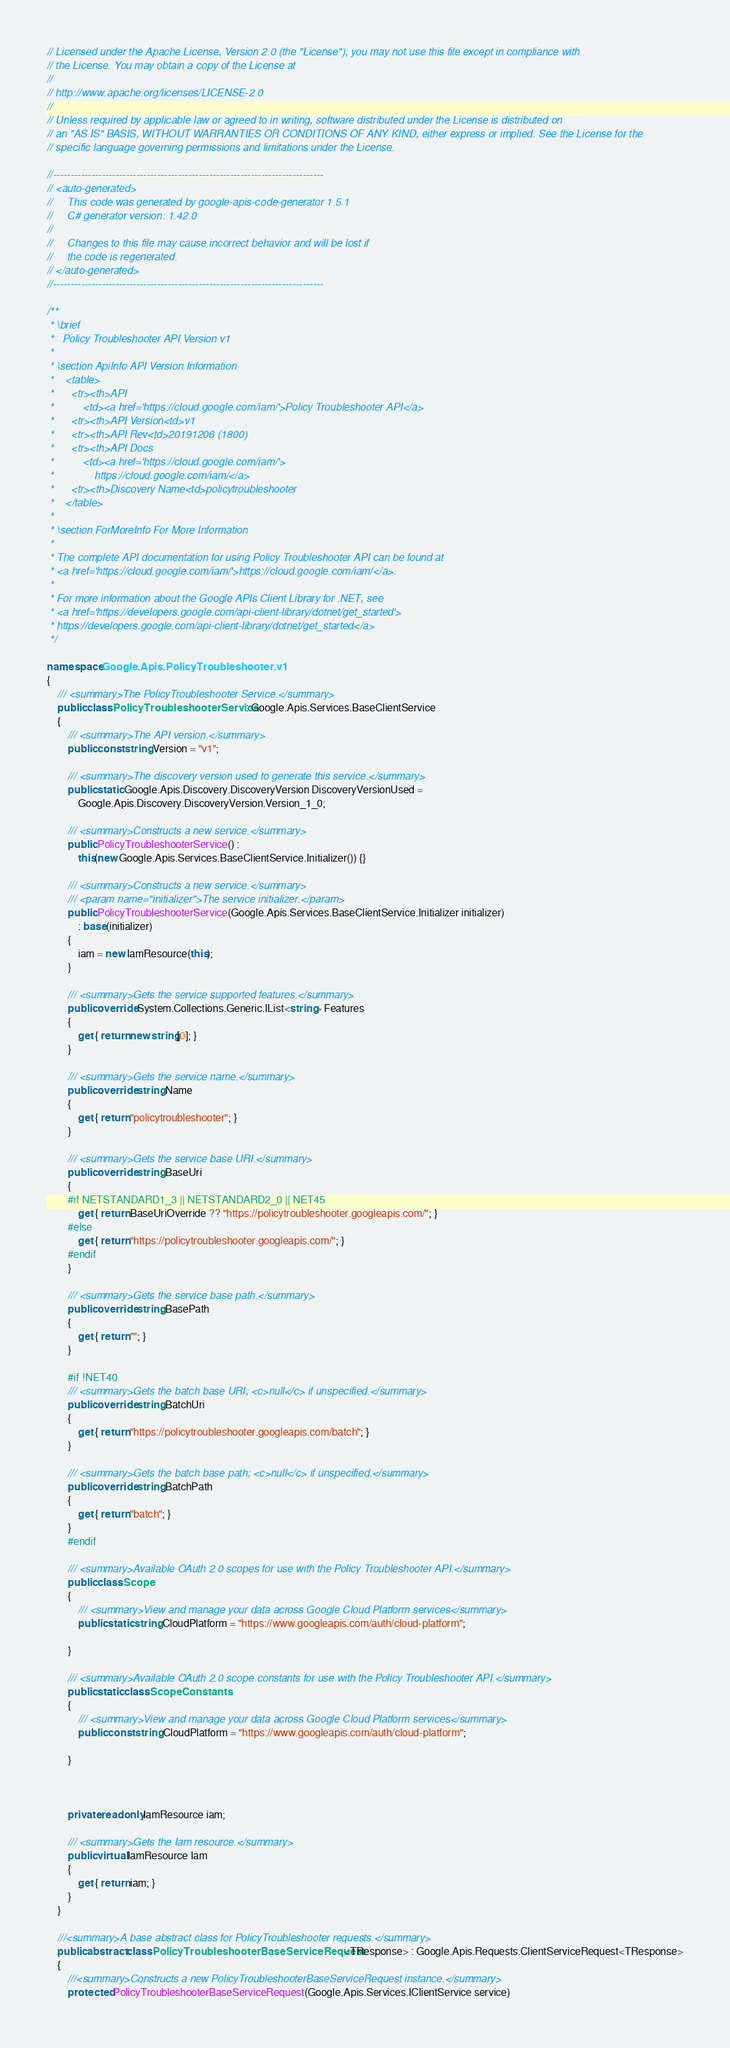Convert code to text. <code><loc_0><loc_0><loc_500><loc_500><_C#_>// Licensed under the Apache License, Version 2.0 (the "License"); you may not use this file except in compliance with
// the License. You may obtain a copy of the License at
//
// http://www.apache.org/licenses/LICENSE-2.0
//
// Unless required by applicable law or agreed to in writing, software distributed under the License is distributed on
// an "AS IS" BASIS, WITHOUT WARRANTIES OR CONDITIONS OF ANY KIND, either express or implied. See the License for the
// specific language governing permissions and limitations under the License.

//------------------------------------------------------------------------------
// <auto-generated>
//     This code was generated by google-apis-code-generator 1.5.1
//     C# generator version: 1.42.0
//
//     Changes to this file may cause incorrect behavior and will be lost if
//     the code is regenerated.
// </auto-generated>
//------------------------------------------------------------------------------

/**
 * \brief
 *   Policy Troubleshooter API Version v1
 *
 * \section ApiInfo API Version Information
 *    <table>
 *      <tr><th>API
 *          <td><a href='https://cloud.google.com/iam/'>Policy Troubleshooter API</a>
 *      <tr><th>API Version<td>v1
 *      <tr><th>API Rev<td>20191206 (1800)
 *      <tr><th>API Docs
 *          <td><a href='https://cloud.google.com/iam/'>
 *              https://cloud.google.com/iam/</a>
 *      <tr><th>Discovery Name<td>policytroubleshooter
 *    </table>
 *
 * \section ForMoreInfo For More Information
 *
 * The complete API documentation for using Policy Troubleshooter API can be found at
 * <a href='https://cloud.google.com/iam/'>https://cloud.google.com/iam/</a>.
 *
 * For more information about the Google APIs Client Library for .NET, see
 * <a href='https://developers.google.com/api-client-library/dotnet/get_started'>
 * https://developers.google.com/api-client-library/dotnet/get_started</a>
 */

namespace Google.Apis.PolicyTroubleshooter.v1
{
    /// <summary>The PolicyTroubleshooter Service.</summary>
    public class PolicyTroubleshooterService : Google.Apis.Services.BaseClientService
    {
        /// <summary>The API version.</summary>
        public const string Version = "v1";

        /// <summary>The discovery version used to generate this service.</summary>
        public static Google.Apis.Discovery.DiscoveryVersion DiscoveryVersionUsed =
            Google.Apis.Discovery.DiscoveryVersion.Version_1_0;

        /// <summary>Constructs a new service.</summary>
        public PolicyTroubleshooterService() :
            this(new Google.Apis.Services.BaseClientService.Initializer()) {}

        /// <summary>Constructs a new service.</summary>
        /// <param name="initializer">The service initializer.</param>
        public PolicyTroubleshooterService(Google.Apis.Services.BaseClientService.Initializer initializer)
            : base(initializer)
        {
            iam = new IamResource(this);
        }

        /// <summary>Gets the service supported features.</summary>
        public override System.Collections.Generic.IList<string> Features
        {
            get { return new string[0]; }
        }

        /// <summary>Gets the service name.</summary>
        public override string Name
        {
            get { return "policytroubleshooter"; }
        }

        /// <summary>Gets the service base URI.</summary>
        public override string BaseUri
        {
        #if NETSTANDARD1_3 || NETSTANDARD2_0 || NET45
            get { return BaseUriOverride ?? "https://policytroubleshooter.googleapis.com/"; }
        #else
            get { return "https://policytroubleshooter.googleapis.com/"; }
        #endif
        }

        /// <summary>Gets the service base path.</summary>
        public override string BasePath
        {
            get { return ""; }
        }

        #if !NET40
        /// <summary>Gets the batch base URI; <c>null</c> if unspecified.</summary>
        public override string BatchUri
        {
            get { return "https://policytroubleshooter.googleapis.com/batch"; }
        }

        /// <summary>Gets the batch base path; <c>null</c> if unspecified.</summary>
        public override string BatchPath
        {
            get { return "batch"; }
        }
        #endif

        /// <summary>Available OAuth 2.0 scopes for use with the Policy Troubleshooter API.</summary>
        public class Scope
        {
            /// <summary>View and manage your data across Google Cloud Platform services</summary>
            public static string CloudPlatform = "https://www.googleapis.com/auth/cloud-platform";

        }

        /// <summary>Available OAuth 2.0 scope constants for use with the Policy Troubleshooter API.</summary>
        public static class ScopeConstants
        {
            /// <summary>View and manage your data across Google Cloud Platform services</summary>
            public const string CloudPlatform = "https://www.googleapis.com/auth/cloud-platform";

        }



        private readonly IamResource iam;

        /// <summary>Gets the Iam resource.</summary>
        public virtual IamResource Iam
        {
            get { return iam; }
        }
    }

    ///<summary>A base abstract class for PolicyTroubleshooter requests.</summary>
    public abstract class PolicyTroubleshooterBaseServiceRequest<TResponse> : Google.Apis.Requests.ClientServiceRequest<TResponse>
    {
        ///<summary>Constructs a new PolicyTroubleshooterBaseServiceRequest instance.</summary>
        protected PolicyTroubleshooterBaseServiceRequest(Google.Apis.Services.IClientService service)</code> 